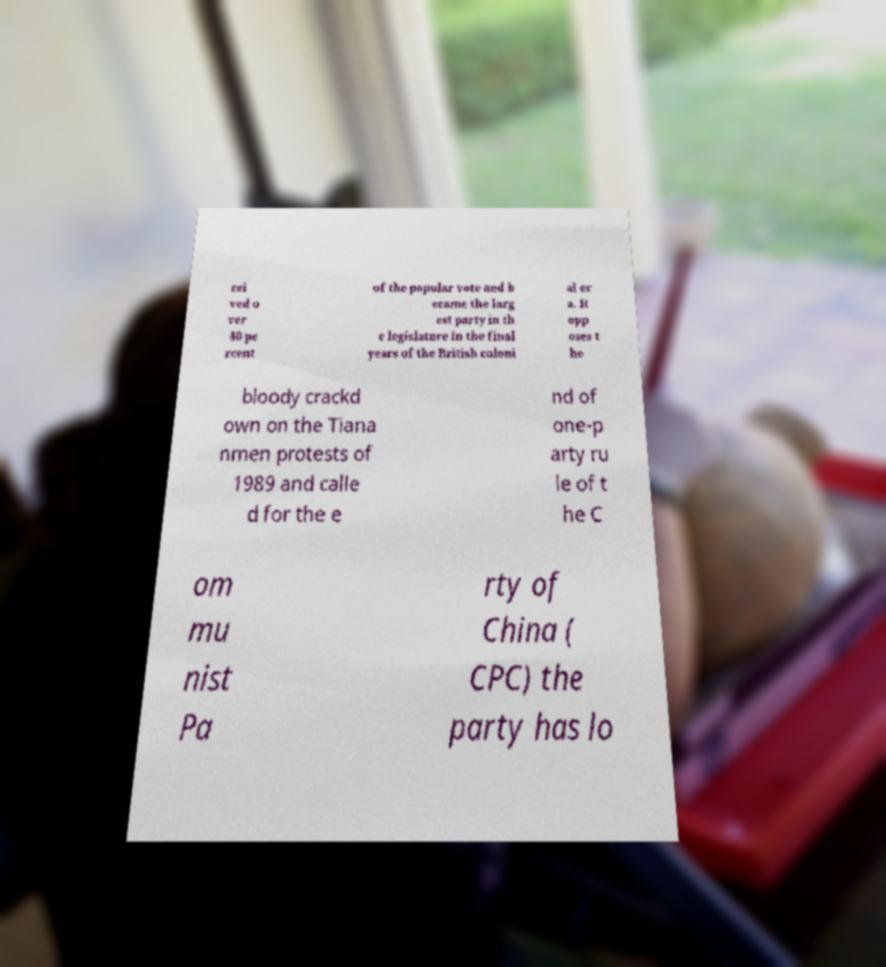Please identify and transcribe the text found in this image. cei ved o ver 40 pe rcent of the popular vote and b ecame the larg est party in th e legislature in the final years of the British coloni al er a. It opp oses t he bloody crackd own on the Tiana nmen protests of 1989 and calle d for the e nd of one-p arty ru le of t he C om mu nist Pa rty of China ( CPC) the party has lo 